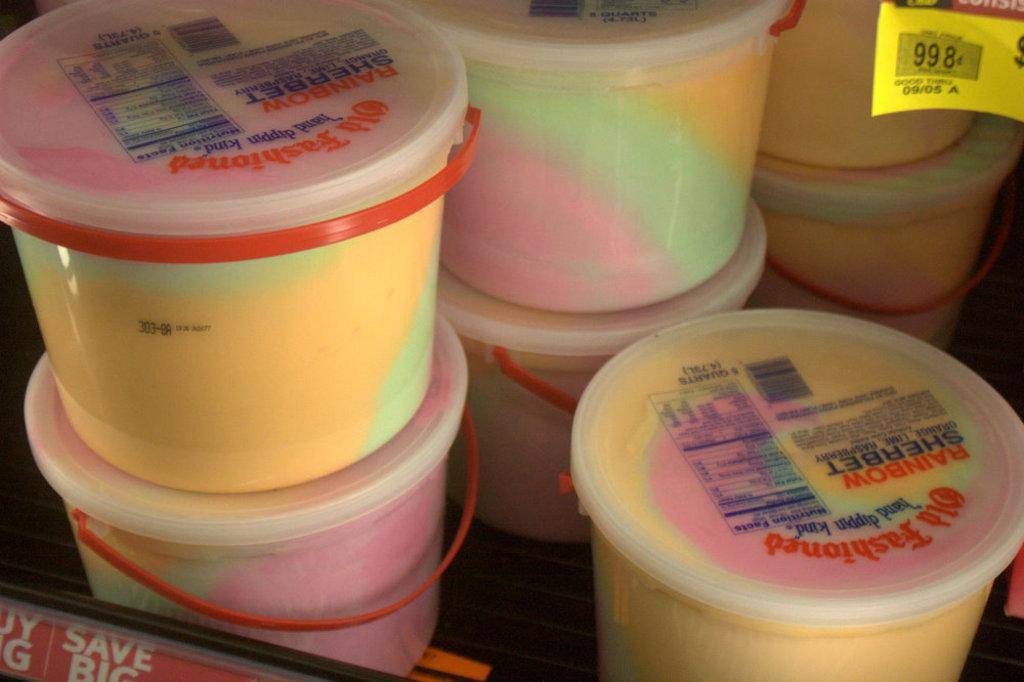<image>
Create a compact narrative representing the image presented. A stack of containers of Old Fashioned rainbow sherbet. 